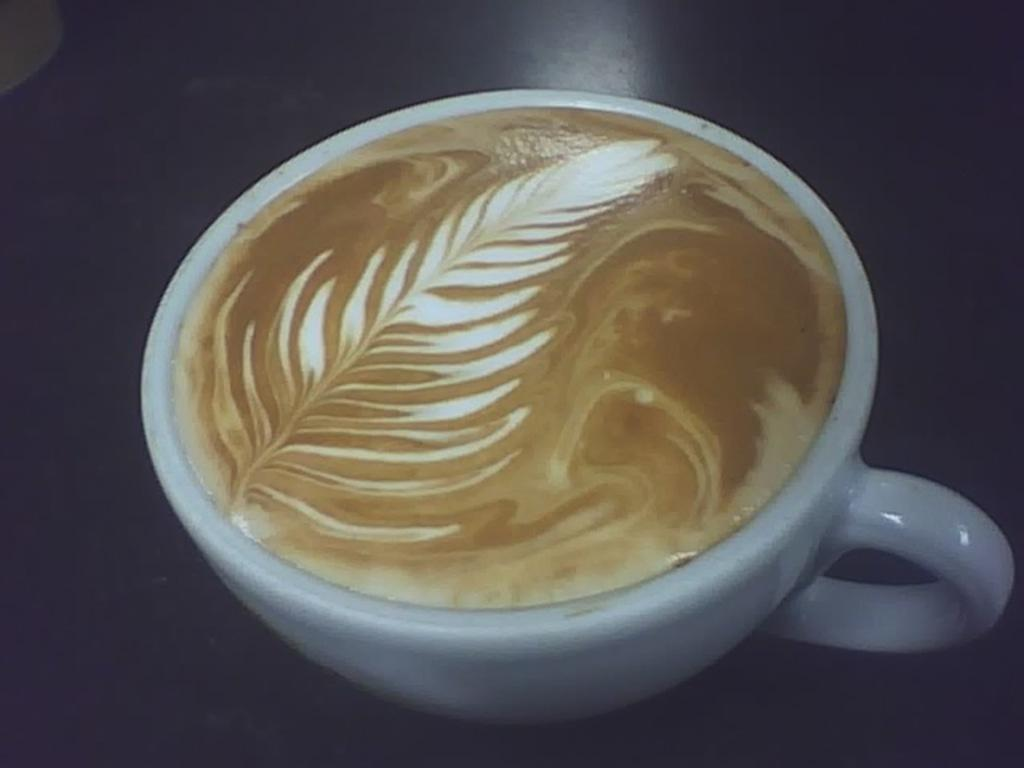What is in the cup that is visible in the image? There is coffee in a cup in the image. What color is the cup? The cup is white. What type of texture can be seen on the metal statement in the image? There is no metal statement present in the image; it only features a white cup with coffee. 